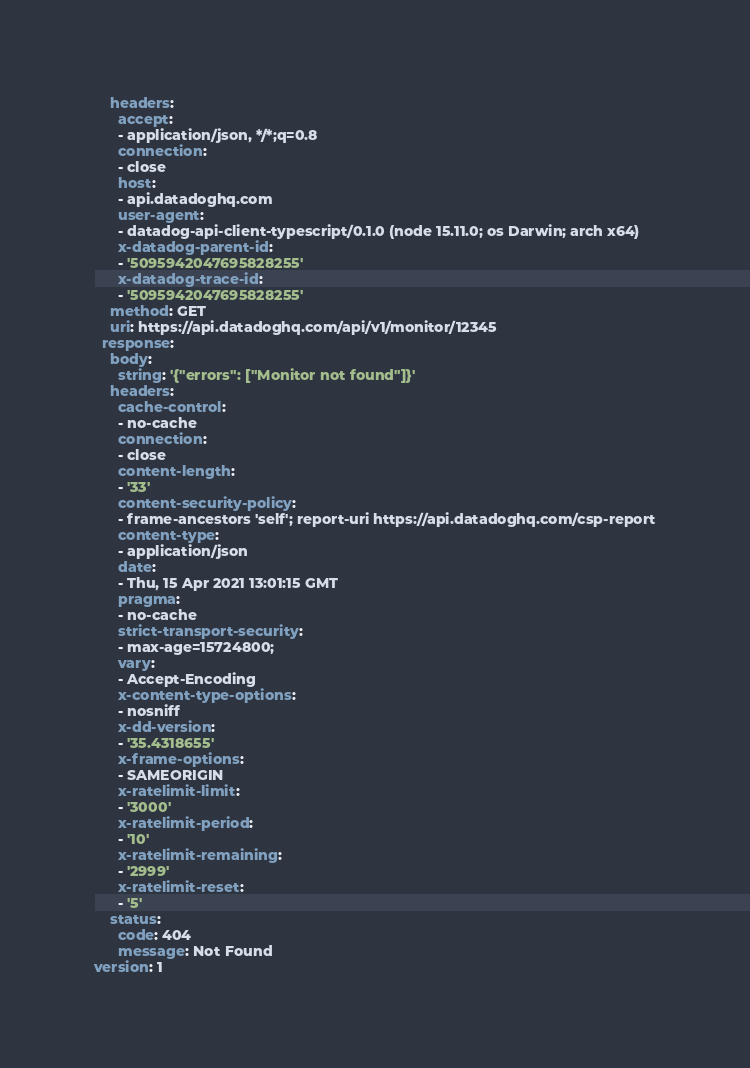Convert code to text. <code><loc_0><loc_0><loc_500><loc_500><_YAML_>    headers:
      accept:
      - application/json, */*;q=0.8
      connection:
      - close
      host:
      - api.datadoghq.com
      user-agent:
      - datadog-api-client-typescript/0.1.0 (node 15.11.0; os Darwin; arch x64)
      x-datadog-parent-id:
      - '5095942047695828255'
      x-datadog-trace-id:
      - '5095942047695828255'
    method: GET
    uri: https://api.datadoghq.com/api/v1/monitor/12345
  response:
    body:
      string: '{"errors": ["Monitor not found"]}'
    headers:
      cache-control:
      - no-cache
      connection:
      - close
      content-length:
      - '33'
      content-security-policy:
      - frame-ancestors 'self'; report-uri https://api.datadoghq.com/csp-report
      content-type:
      - application/json
      date:
      - Thu, 15 Apr 2021 13:01:15 GMT
      pragma:
      - no-cache
      strict-transport-security:
      - max-age=15724800;
      vary:
      - Accept-Encoding
      x-content-type-options:
      - nosniff
      x-dd-version:
      - '35.4318655'
      x-frame-options:
      - SAMEORIGIN
      x-ratelimit-limit:
      - '3000'
      x-ratelimit-period:
      - '10'
      x-ratelimit-remaining:
      - '2999'
      x-ratelimit-reset:
      - '5'
    status:
      code: 404
      message: Not Found
version: 1
</code> 